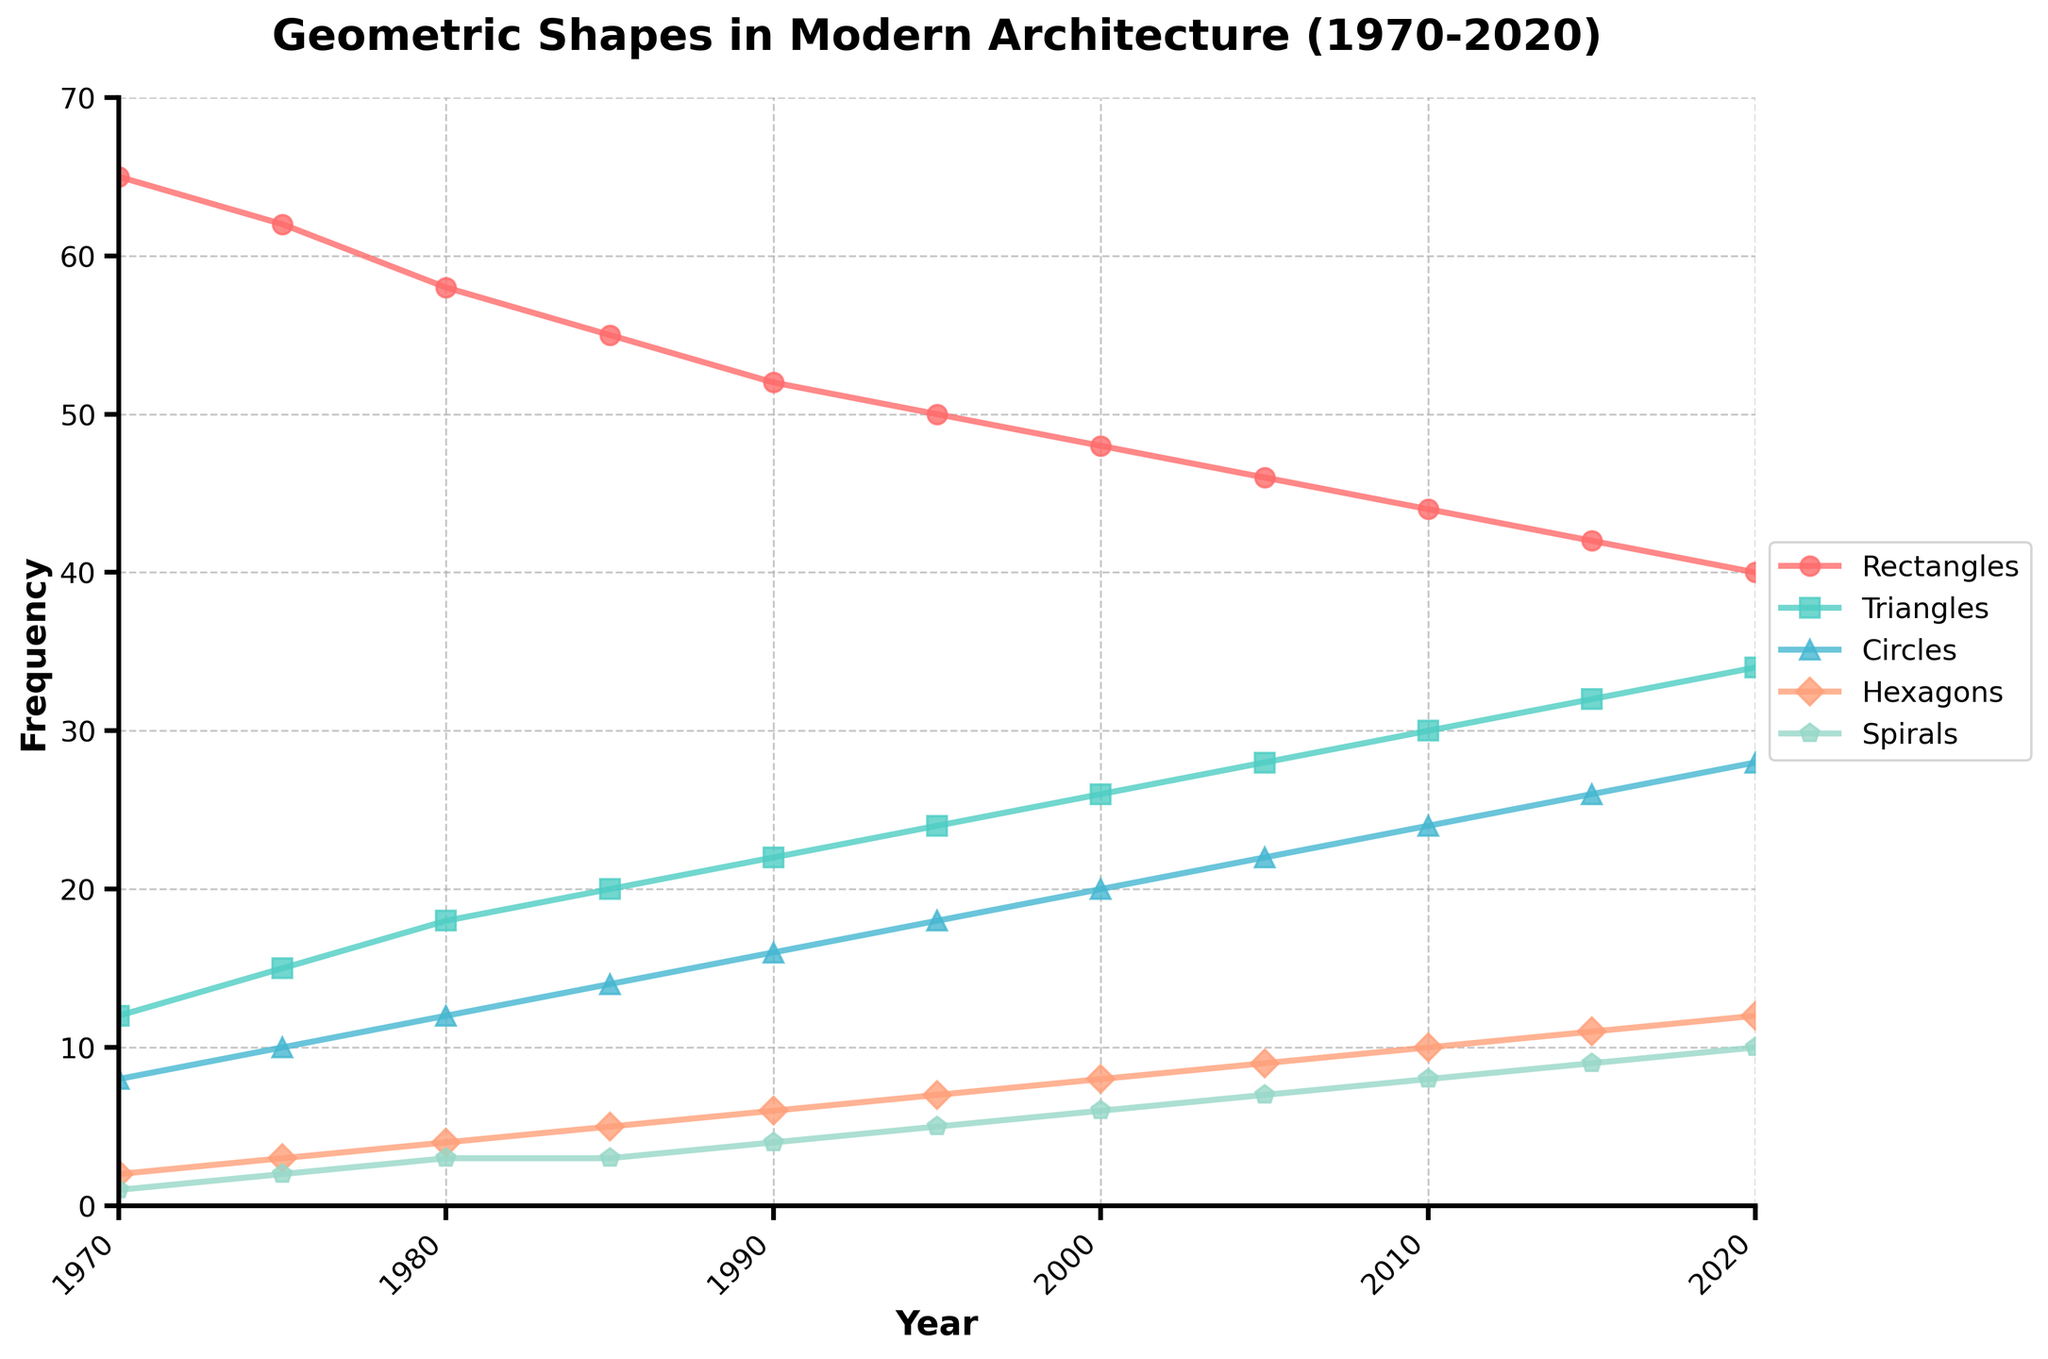What is the overall trend of rectangle usage over the last 50 years? The rectangle usage shows a consistent downward trend. Starting from 65 in 1970, it gradually decreases to 40 by 2020, indicating a steady decline in their frequency.
Answer: Downward trend Between which years do triangles see the highest increase in frequency? To determine the highest increase, compare the differences in triangle frequencies across each interval. The highest increases are from 1985 to 1990 (2 units increase) and from 2015 to 2020 (2 units increase). Comparing the values, both show the same highest increase.
Answer: 1985-1990 or 2015-2020 How does the frequency of circles in 2000 compare to the frequency of hexagons in the same year? According to the data, the frequency of circles in 2000 is 20, whereas the frequency of hexagons in 2000 is 8. Comparing these values, circles have a higher frequency.
Answer: Circles are higher What is the frequency change of spirals from 1970 to 2020? The initial frequency of spirals in 1970 is 1 and increases to 10 by 2020. The change in frequency can be calculated by subtracting the initial value from the final value: 10 - 1 = 9.
Answer: Increase of 9 Which geometric shape had the most consistent increase in frequency over the 50-year period? By observing the slopes of the lines, triangles have a consistent increase in frequency, starting at 12 in 1970 and increasing steadily to 34 in 2020 without any significant fluctuations.
Answer: Triangles How much more frequent were rectangles than circles in 1990? In 1990, the frequency of rectangles is 52, and the frequency of circles is 16. The difference can be calculated by subtracting the frequency of circles from rectangles: 52 - 16 = 36.
Answer: 36 Of all the geometric shapes shown, which had the lowest initial frequency in 1970? By examining the initial values in 1970, spirals had the lowest frequency with a value of 1.
Answer: Spirals Compare the frequency trends of hexagons and spirals from 1970 to 2020. Both hexagons and spirals show an increasing trend. Hexagons start from 2 and rise to 12, whereas spirals start from 1 and rise to 10. While the trends are similar, hexagons increase more steeply compared to spirals.
Answer: Both increasing (with hexagons steeper) What average frequency do triangles show over the 50 years? To find the average frequency of triangles, sum their frequencies from each year (12+15+18+20+22+24+26+28+30+32+34) and divide by the number of years (11). The sum is 261, so the average is 261/11 ≈ 23.73.
Answer: 23.73 